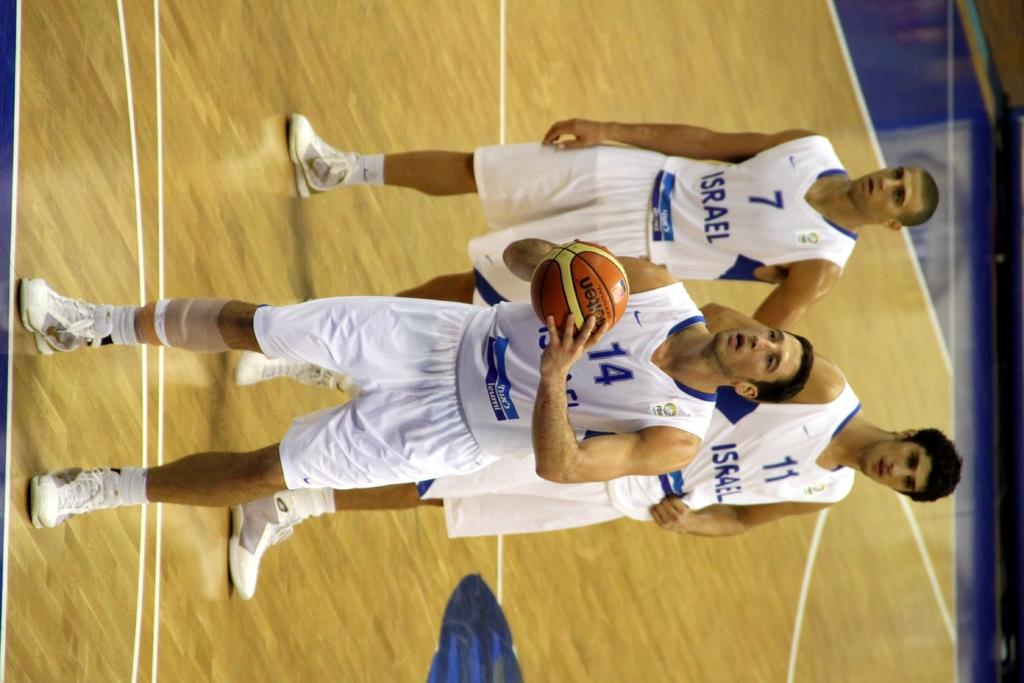How many people are in the image? There are three persons in the image. What are the three persons doing? The three persons are standing and appear to be playing. What object is one person holding? One person is holding a basketball. What can be seen in the background of the image? There is a floor visible in the background of the image. What type of grass is growing on the territory in the image? There is no grass or territory present in the image; it features three people standing and playing with a basketball. Can you describe the trail that the persons are following in the image? There is no trail visible in the image; the persons are standing and playing with a basketball on a floor. 